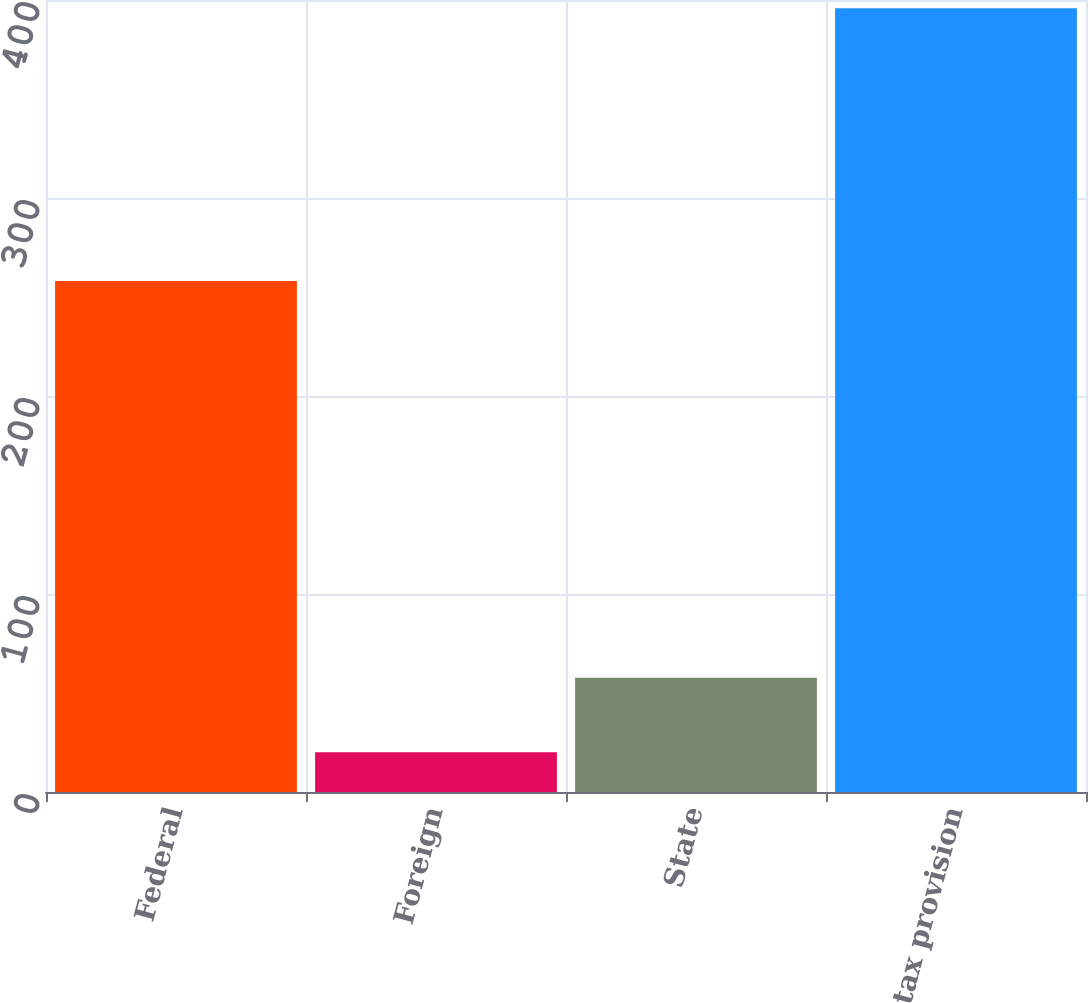Convert chart. <chart><loc_0><loc_0><loc_500><loc_500><bar_chart><fcel>Federal<fcel>Foreign<fcel>State<fcel>Income tax provision<nl><fcel>258.1<fcel>20.1<fcel>57.67<fcel>395.8<nl></chart> 